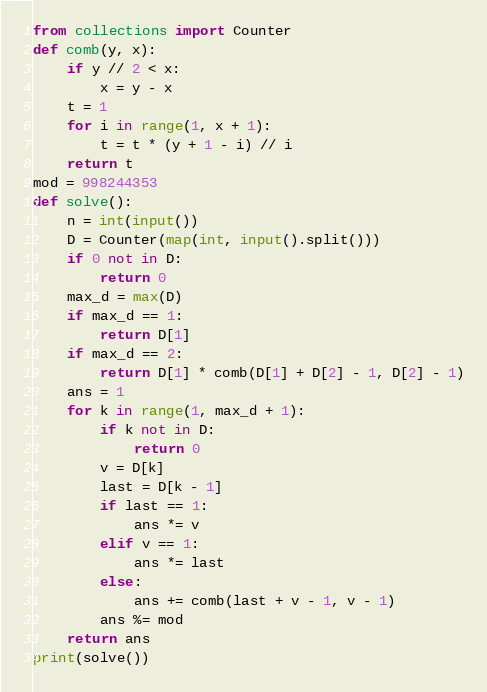Convert code to text. <code><loc_0><loc_0><loc_500><loc_500><_Python_>from collections import Counter
def comb(y, x):
    if y // 2 < x:
        x = y - x
    t = 1
    for i in range(1, x + 1):
        t = t * (y + 1 - i) // i
    return t
mod = 998244353
def solve():
    n = int(input())
    D = Counter(map(int, input().split()))
    if 0 not in D:
        return 0
    max_d = max(D)
    if max_d == 1:
        return D[1]
    if max_d == 2:
        return D[1] * comb(D[1] + D[2] - 1, D[2] - 1)
    ans = 1
    for k in range(1, max_d + 1):
        if k not in D:
            return 0
        v = D[k]
        last = D[k - 1]
        if last == 1:
            ans *= v
        elif v == 1:
            ans *= last
        else:
            ans += comb(last + v - 1, v - 1)
        ans %= mod
    return ans
print(solve())
</code> 